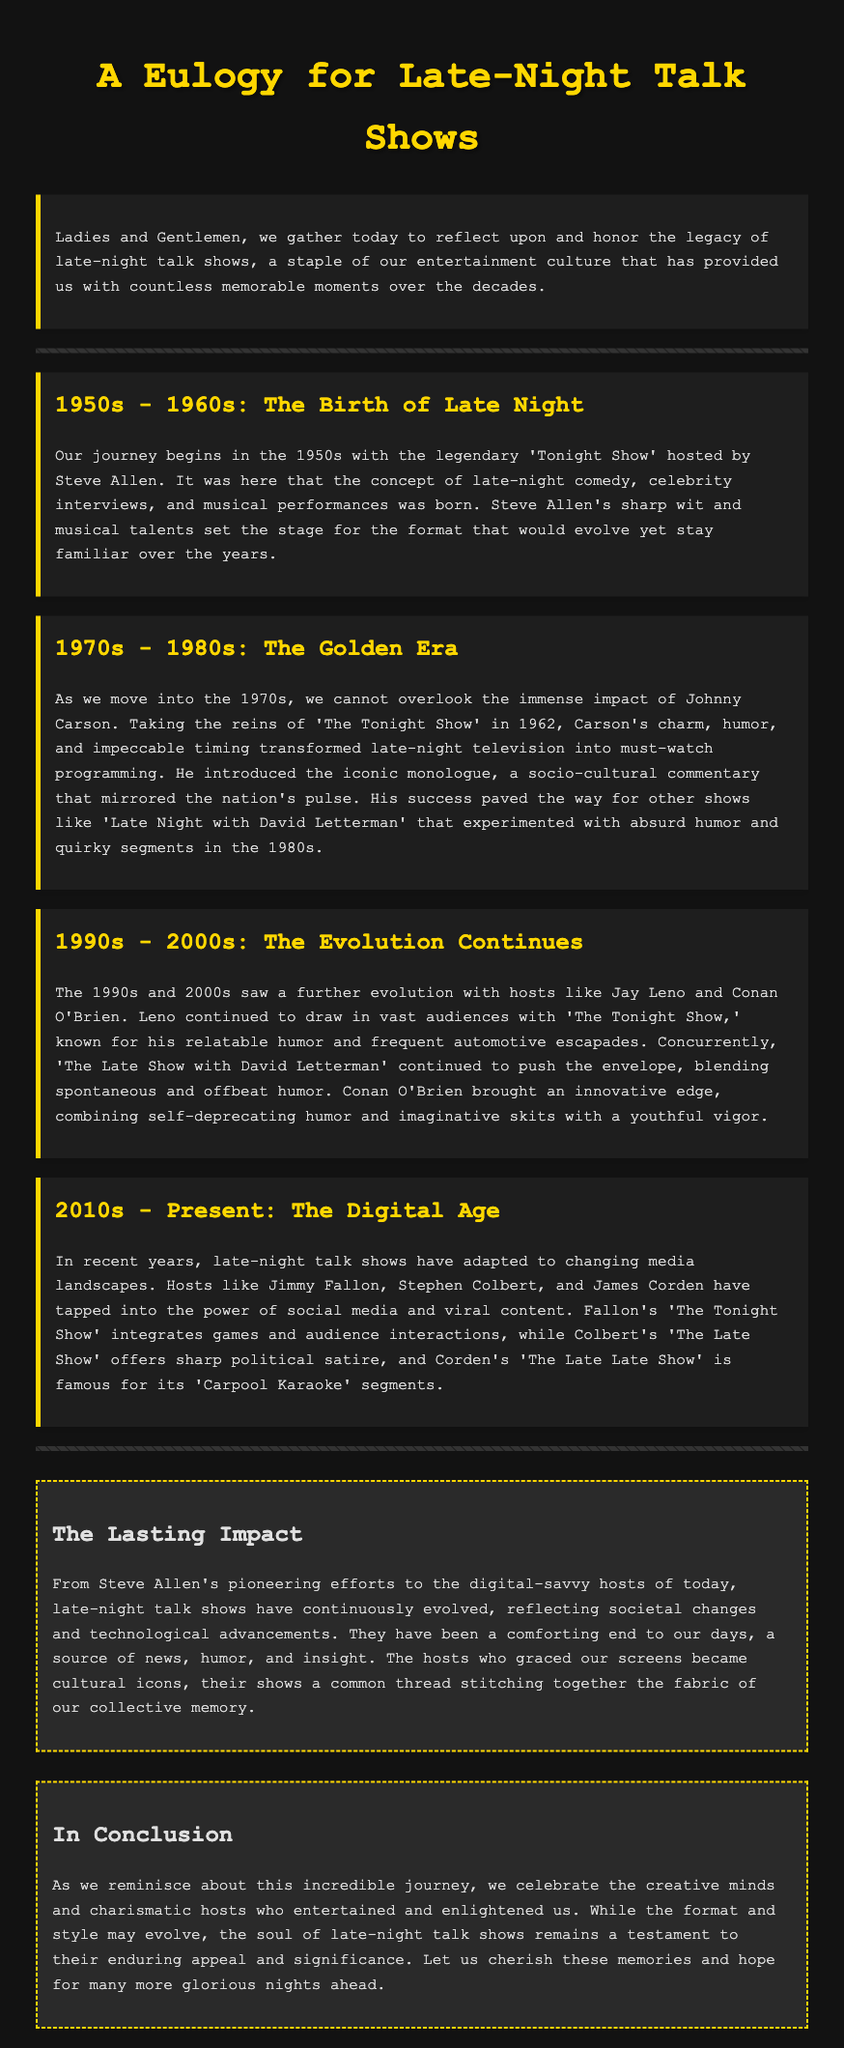What show is credited with the birth of late-night talk shows? The document states that the legendary 'Tonight Show' hosted by Steve Allen marked the beginning of late-night comedy.
Answer: 'Tonight Show' Who hosted 'The Tonight Show' in the 1970s? Johnny Carson took the reins of 'The Tonight Show' in 1962, which had a significant impact during the 1970s.
Answer: Johnny Carson What segment did Jimmy Fallon integrate into 'The Tonight Show'? The document mentions that Fallon's 'The Tonight Show' includes games and audience interactions.
Answer: Games Which host is famous for 'Carpool Karaoke'? The document indicates that James Corden's show is well-known for the 'Carpool Karaoke' segments.
Answer: James Corden What decade is known as the Golden Era of late-night talk shows? The document refers to the 1970s - 1980s as the Golden Era due to the impact of Johnny Carson.
Answer: 1970s - 1980s What type of humor did Conan O'Brien bring to late-night television? According to the document, Conan O'Brien combined self-deprecating humor and imaginative skits.
Answer: Self-deprecating humor What is the primary theme of the conclusion? The conclusion emphasizes cherishing memories and the enduring appeal of late-night talk shows.
Answer: Cherishing memories In what year did Steve Allen begin hosting 'The Tonight Show'? The document mentions that the show started in the 1950s, and Steve Allen was the host during that time.
Answer: 1950s 